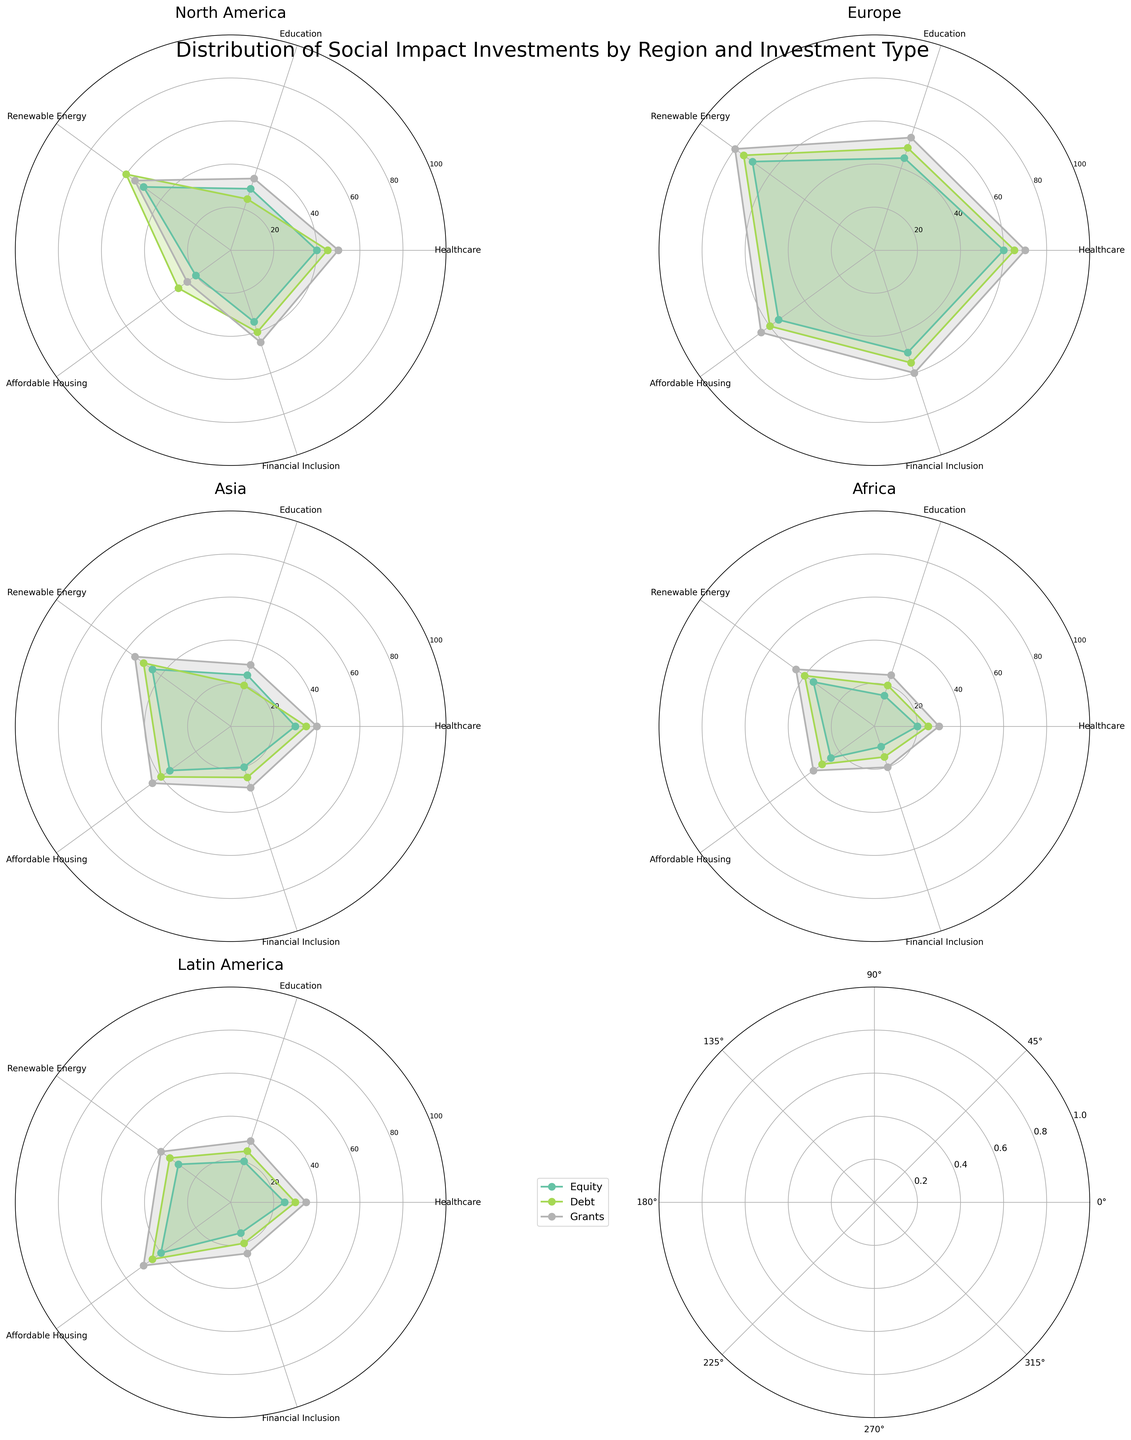What is the title of the figure? The title is located at the top of the figure and is clearly displayed in a larger font size.
Answer: Distribution of Social Impact Investments by Region and Investment Type Which region shows the highest investment in Renewable Energy through Grants? By examining the plot for each region, find the one with the highest value on the Renewable Energy axis for the Grants investment type.
Answer: Europe Which Investment Type in North America has the lowest allocation for Affordable Housing? Look at the Affordable Housing axis in the North America subplot to identify which investment type has the smallest value.
Answer: Equity Which region has the most balanced investment across all the sectors and investment types? A balanced investment would imply closer values across all sectors; visually inspect all subplots to see which has the least disparity.
Answer: Europe Compare the investment in Healthcare through Debt investments between Asia and Africa. Which region has more investment? Look at the Healthcare axis for Debt investments in both Asia and Africa. Compare the values to determine which is higher.
Answer: Asia What is the average investment in Financial Inclusion in Latin America for all investment types? Sum the values of Financial Inclusion for all three investment types in Latin America and then divide by 3 to find the average.
Answer: (15 + 20 + 25) / 3 = 20 Which region has the highest equity investment in Education? By examining the Education axis for each region's Equity investment type, find the region with the highest value.
Answer: Europe What is the difference in investment in Renewable Energy through Debt investments between Europe and North America? Subtract the Renewable Energy value for Debt investments in North America from the value in Europe.
Answer: 75 - 60 = 15 Which investment type in Asia has the highest allocation for Renewable Energy? Look at the Renewable Energy axis in the Asia subplot to see which investment type has the highest value.
Answer: Grants Identify the region with the lowest healthcare investment across all investment types. Compare the Healthcare values for all investment types across all regions to find the region with the lowest value.
Answer: Africa 